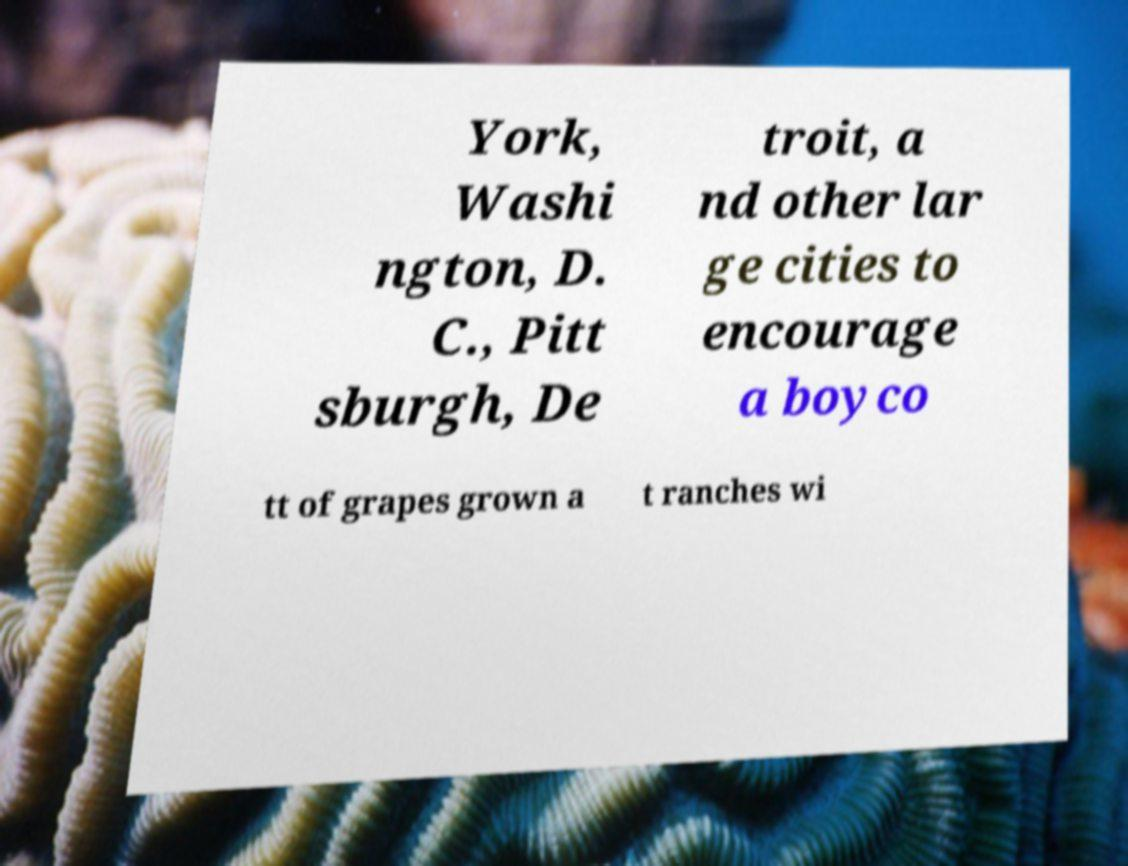Could you assist in decoding the text presented in this image and type it out clearly? York, Washi ngton, D. C., Pitt sburgh, De troit, a nd other lar ge cities to encourage a boyco tt of grapes grown a t ranches wi 